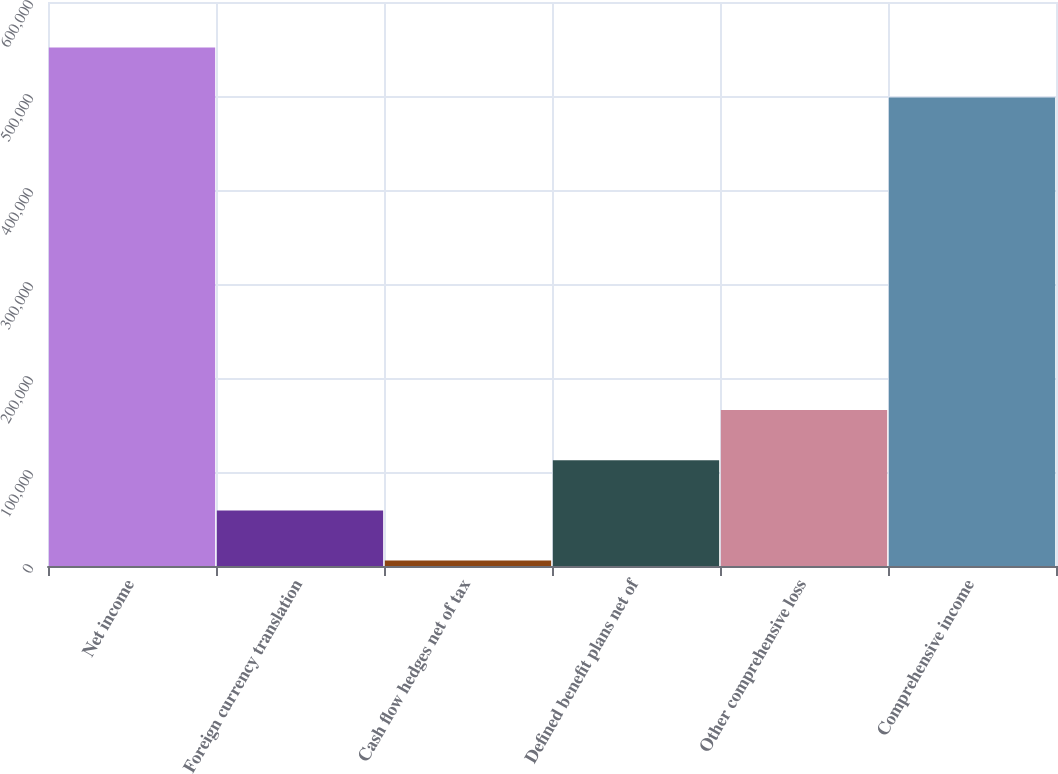Convert chart. <chart><loc_0><loc_0><loc_500><loc_500><bar_chart><fcel>Net income<fcel>Foreign currency translation<fcel>Cash flow hedges net of tax<fcel>Defined benefit plans net of<fcel>Other comprehensive loss<fcel>Comprehensive income<nl><fcel>551686<fcel>59119.5<fcel>5757<fcel>112482<fcel>165844<fcel>498324<nl></chart> 